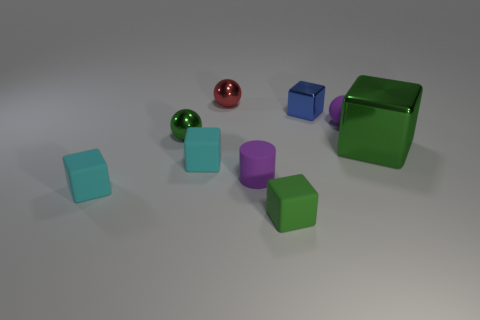Subtract all brown cylinders. How many cyan cubes are left? 2 Subtract all metal cubes. How many cubes are left? 3 Subtract all blue cubes. How many cubes are left? 4 Subtract 1 cubes. How many cubes are left? 4 Add 1 big green shiny objects. How many objects exist? 10 Subtract all balls. How many objects are left? 6 Add 4 purple matte spheres. How many purple matte spheres exist? 5 Subtract 1 purple cylinders. How many objects are left? 8 Subtract all green spheres. Subtract all red cylinders. How many spheres are left? 2 Subtract all large gray metallic objects. Subtract all green blocks. How many objects are left? 7 